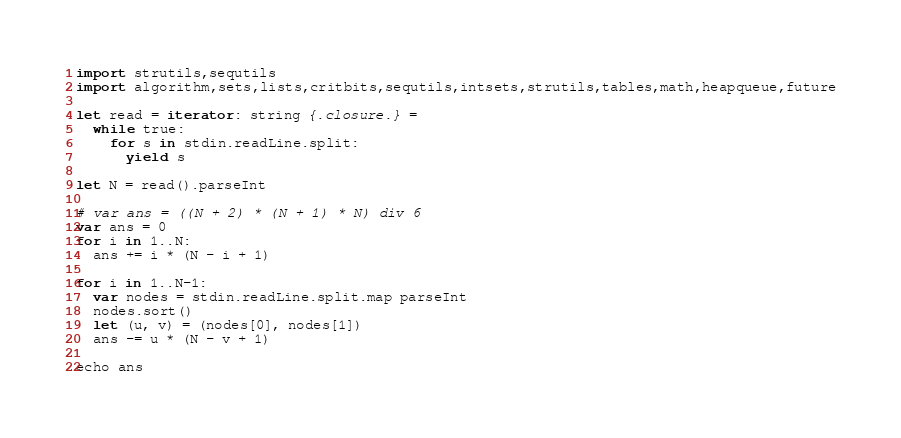<code> <loc_0><loc_0><loc_500><loc_500><_Nim_>import strutils,sequtils
import algorithm,sets,lists,critbits,sequtils,intsets,strutils,tables,math,heapqueue,future

let read = iterator: string {.closure.} =
  while true:
    for s in stdin.readLine.split:
      yield s

let N = read().parseInt

# var ans = ((N + 2) * (N + 1) * N) div 6
var ans = 0
for i in 1..N:
  ans += i * (N - i + 1)

for i in 1..N-1:
  var nodes = stdin.readLine.split.map parseInt
  nodes.sort()
  let (u, v) = (nodes[0], nodes[1])
  ans -= u * (N - v + 1)

echo ans
</code> 